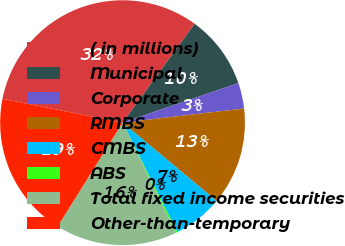Convert chart to OTSL. <chart><loc_0><loc_0><loc_500><loc_500><pie_chart><fcel>( in millions)<fcel>Municipal<fcel>Corporate<fcel>RMBS<fcel>CMBS<fcel>ABS<fcel>Total fixed income securities<fcel>Other-than-temporary<nl><fcel>31.91%<fcel>9.73%<fcel>3.39%<fcel>12.9%<fcel>6.56%<fcel>0.22%<fcel>16.06%<fcel>19.23%<nl></chart> 